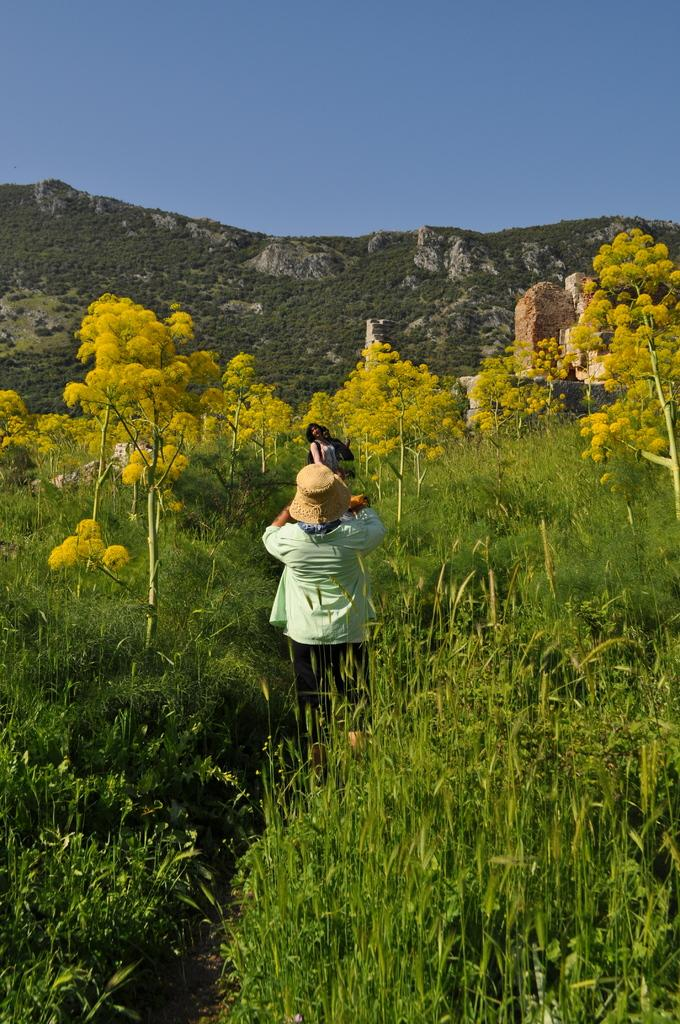What can be seen in the image involving human presence? There are people standing in the image. What type of vegetation is present in the image? There are plants and trees in the image. What geological features can be observed in the image? There are rocks and a hill in the image. What part of the natural environment is visible in the background of the image? The sky is visible in the background of the image. Can you describe the stocking that the people are wearing in the image? There is no mention of stockings or any clothing items in the image; the focus is on the people, plants, trees, rocks, hill, and sky. What type of ocean can be seen in the image? There is no ocean present in the image; it features a hill, trees, plants, rocks, and people. 